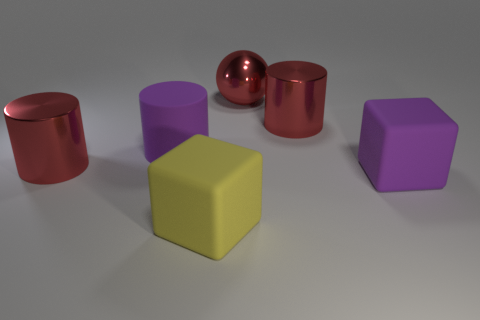How many metal objects are big red cylinders or green cubes?
Give a very brief answer. 2. Do the purple object that is on the left side of the yellow block and the big rubber object on the right side of the yellow thing have the same shape?
Provide a short and direct response. No. Are there any large cubes that have the same material as the big yellow object?
Your response must be concise. Yes. The matte cylinder has what color?
Your answer should be compact. Purple. How big is the cylinder right of the purple cylinder?
Ensure brevity in your answer.  Large. What number of objects have the same color as the metal sphere?
Offer a very short reply. 2. Are there any big red metallic cylinders that are in front of the large red cylinder left of the purple matte cylinder?
Make the answer very short. No. Is the color of the matte thing behind the large purple block the same as the big matte cube that is right of the yellow cube?
Provide a short and direct response. Yes. There is a matte cylinder that is the same size as the yellow matte block; what color is it?
Offer a very short reply. Purple. Is the number of large purple objects that are on the right side of the big purple rubber block the same as the number of metal cylinders that are in front of the yellow cube?
Provide a succinct answer. Yes. 